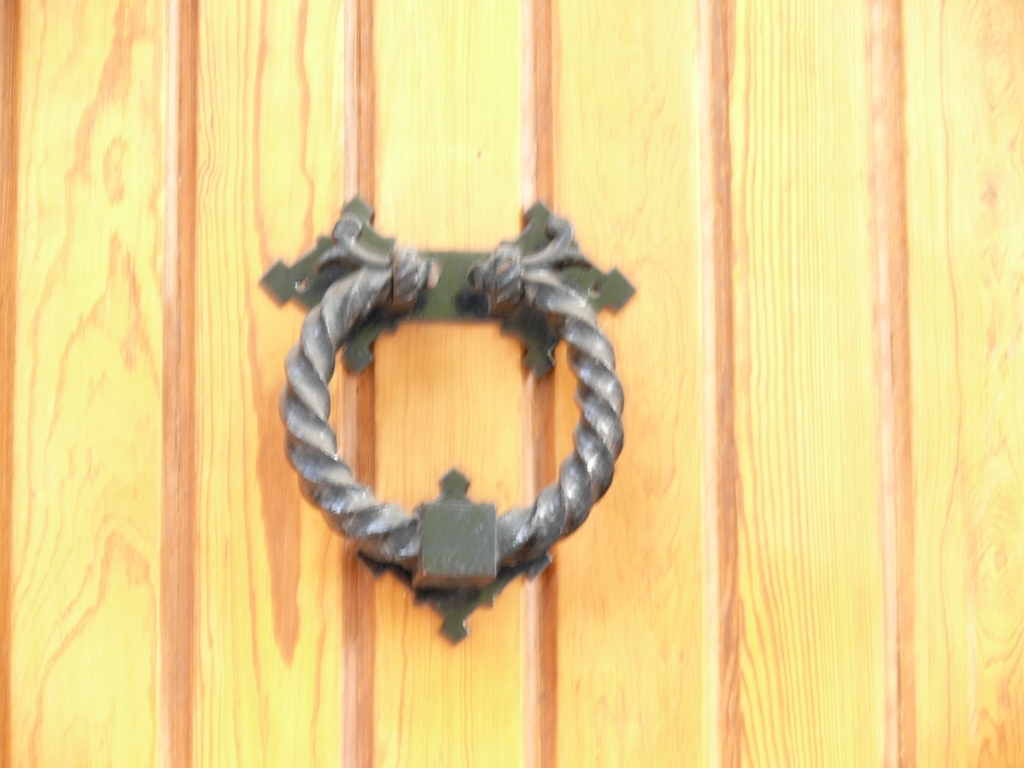What style or era does this door knocker represent? This door knocker has a traditional design, possibly reminiscent of styles commonly seen in the Victorian era. Its wrought iron construction and rustic aesthetic give it a classic and enduring look. 